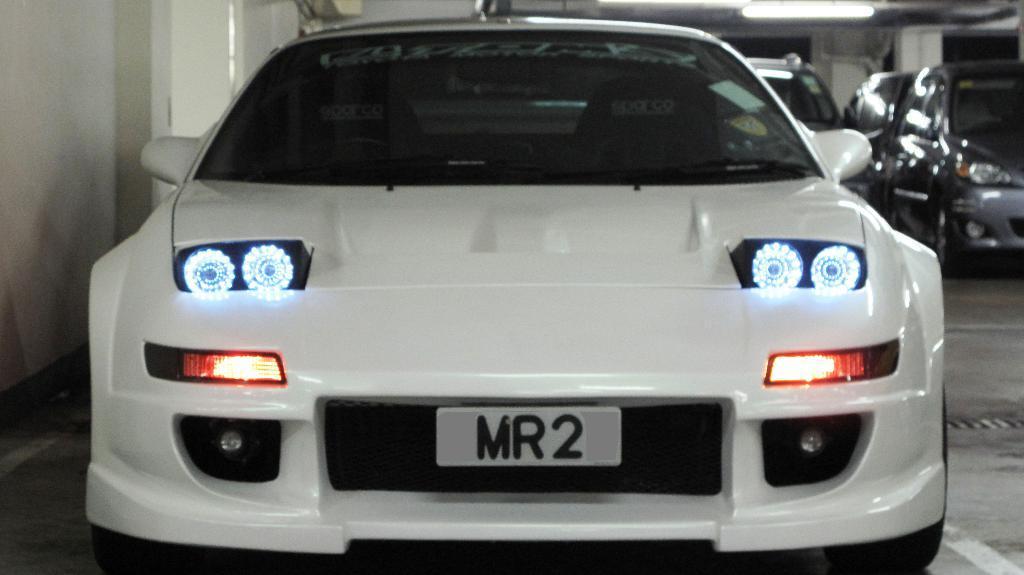Describe this image in one or two sentences. Here we can see vehicles. To this vehicle there is a number plate and headlights. Far there is a tube light. 